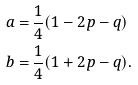<formula> <loc_0><loc_0><loc_500><loc_500>a = & \, \frac { 1 } { 4 } ( 1 - 2 p - q ) \\ b = & \, \frac { 1 } { 4 } ( 1 + 2 p - q ) .</formula> 